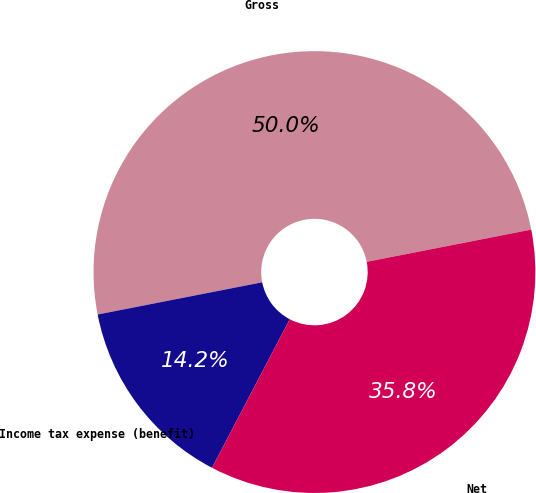<chart> <loc_0><loc_0><loc_500><loc_500><pie_chart><fcel>Gross<fcel>Income tax expense (benefit)<fcel>Net<nl><fcel>50.0%<fcel>14.25%<fcel>35.75%<nl></chart> 